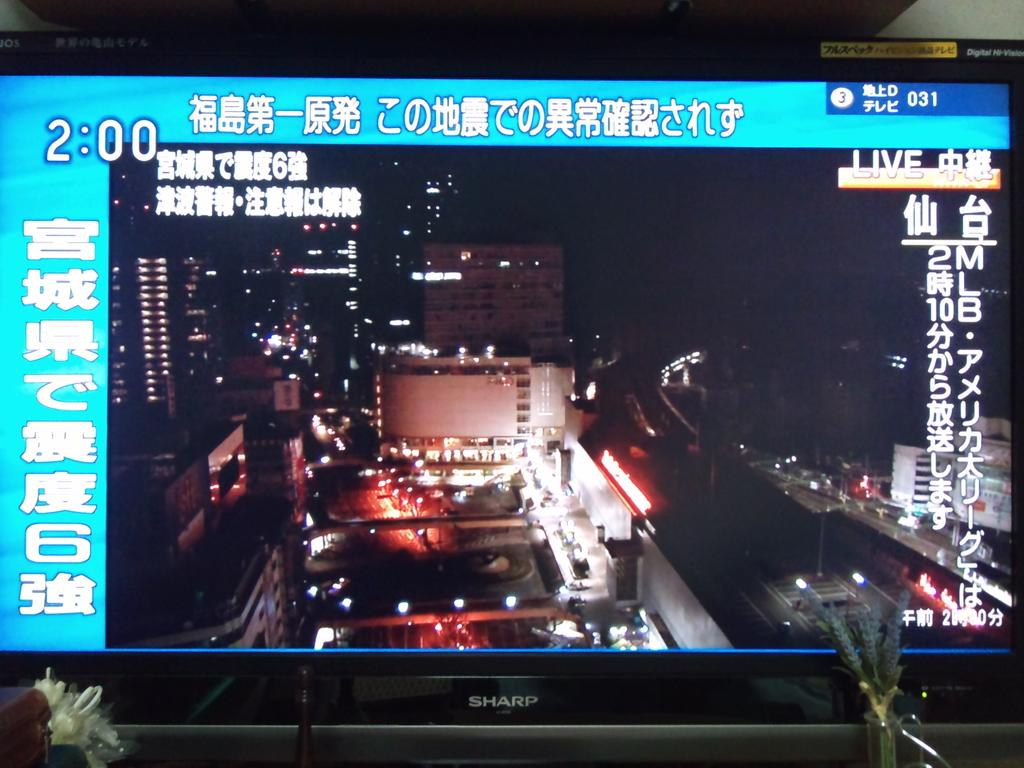<image>
Offer a succinct explanation of the picture presented. The time, 2:00, is displayed on a monitor made by Sharp. 